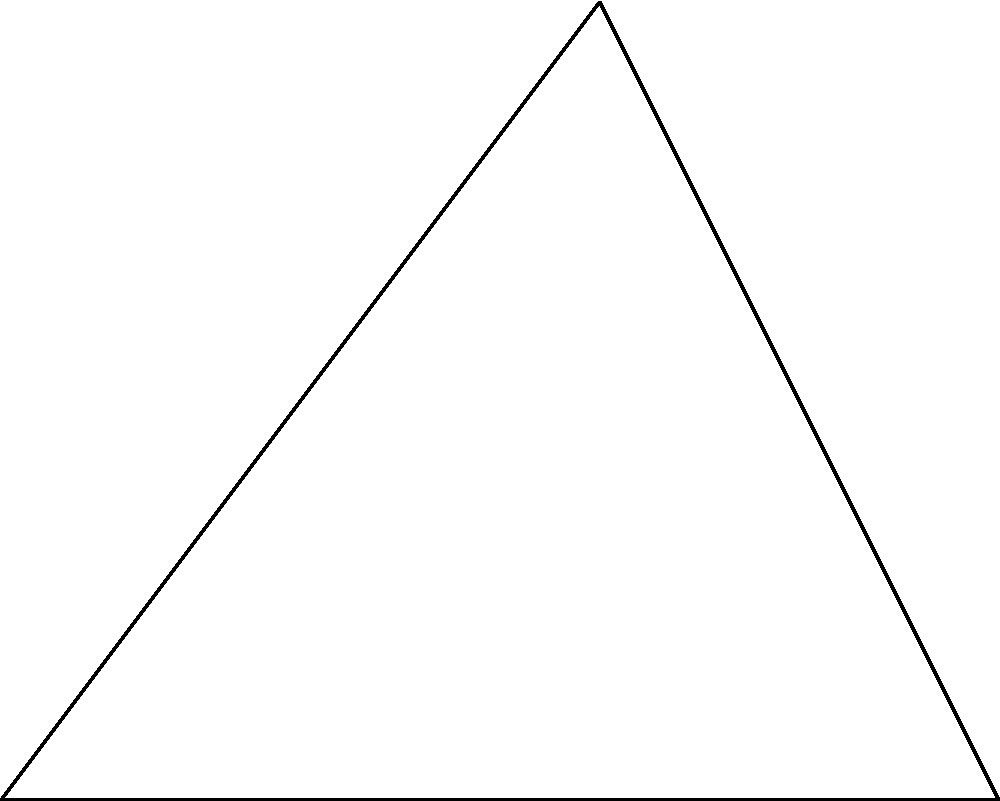A robot arm is anchored at point O(0,0) and has a length of 5 units. It needs to rotate to reach a target point B(5,0). Given that the arm's initial position is at point A(3,4), calculate the angle $\theta$ (in degrees) through which the arm must rotate clockwise to reach the target. To solve this problem, we'll follow these steps:

1) First, we need to calculate the initial angle of the arm relative to the positive x-axis:
   $$\alpha = \tan^{-1}(\frac{4}{3}) \approx 53.13°$$

2) Next, we calculate the angle between the positive x-axis and the line OB:
   $$\beta = \tan^{-1}(\frac{0}{5}) = 0°$$

3) The angle of rotation $\theta$ is the difference between these angles:
   $$\theta = \alpha - \beta = 53.13° - 0° = 53.13°$$

4) However, we need to rotate clockwise, so we subtract this from 360°:
   $$\theta_{clockwise} = 360° - 53.13° = 306.87°$$

5) Round to two decimal places:
   $$\theta_{clockwise} \approx 306.87°$$

Therefore, the robot arm needs to rotate 306.87° clockwise to reach the target point.
Answer: 306.87° 